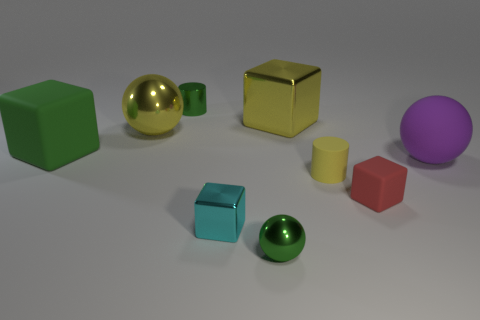Subtract all balls. How many objects are left? 6 Subtract all yellow balls. Subtract all blocks. How many objects are left? 4 Add 1 small green balls. How many small green balls are left? 2 Add 2 cyan cubes. How many cyan cubes exist? 3 Subtract 0 gray blocks. How many objects are left? 9 